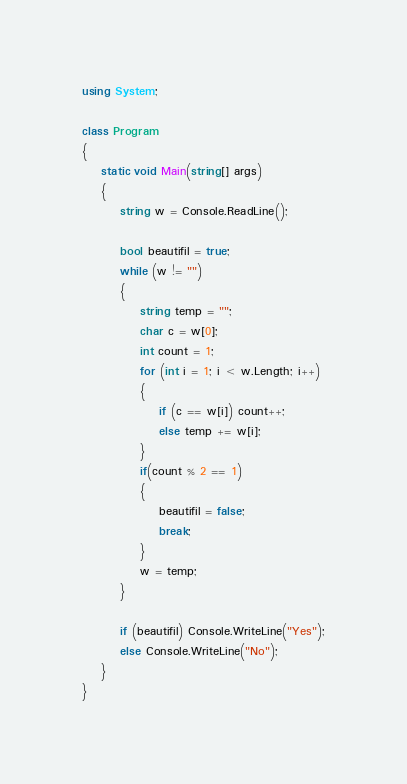Convert code to text. <code><loc_0><loc_0><loc_500><loc_500><_C#_>using System;

class Program
{
    static void Main(string[] args)
    {
        string w = Console.ReadLine();

        bool beautifil = true;
        while (w != "")
        {
            string temp = "";
            char c = w[0];
            int count = 1;
            for (int i = 1; i < w.Length; i++)
            {
                if (c == w[i]) count++;
                else temp += w[i];
            }
            if(count % 2 == 1)
            {
                beautifil = false;
                break;
            }            
            w = temp;
        }

        if (beautifil) Console.WriteLine("Yes");
        else Console.WriteLine("No");
    }
}</code> 